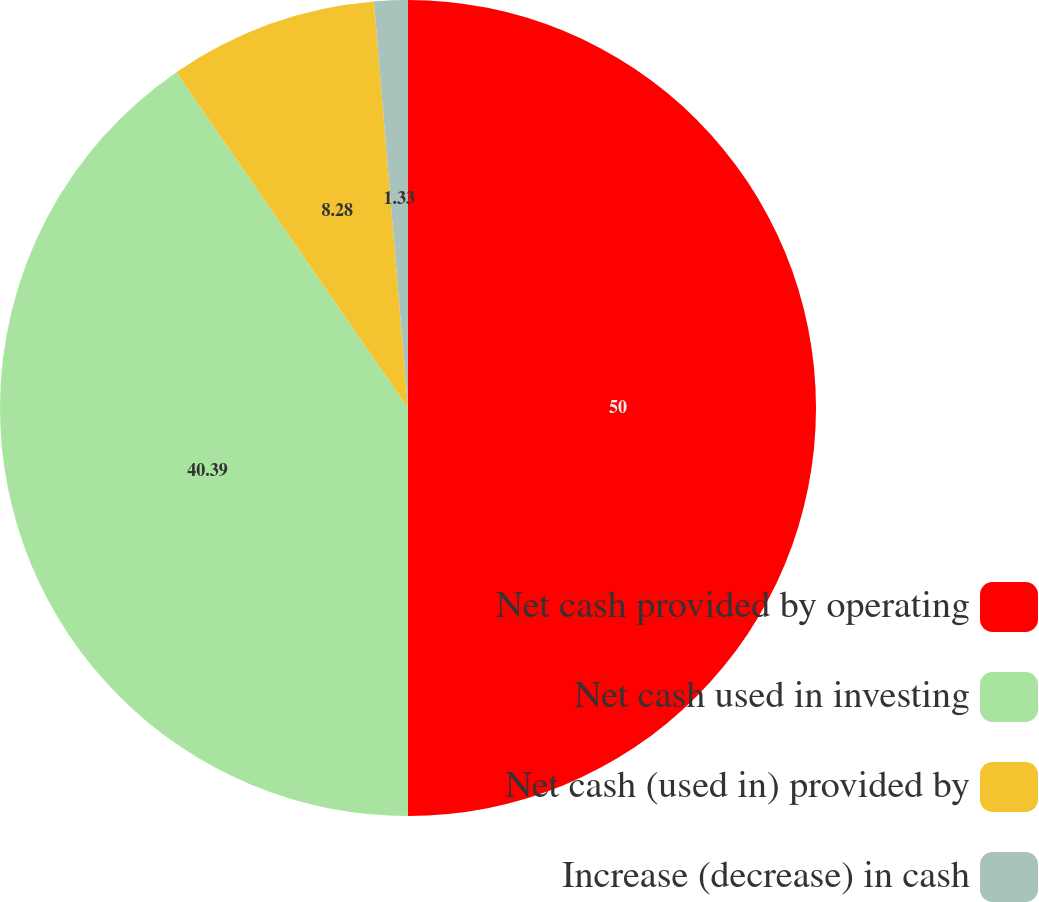Convert chart to OTSL. <chart><loc_0><loc_0><loc_500><loc_500><pie_chart><fcel>Net cash provided by operating<fcel>Net cash used in investing<fcel>Net cash (used in) provided by<fcel>Increase (decrease) in cash<nl><fcel>50.0%<fcel>40.39%<fcel>8.28%<fcel>1.33%<nl></chart> 